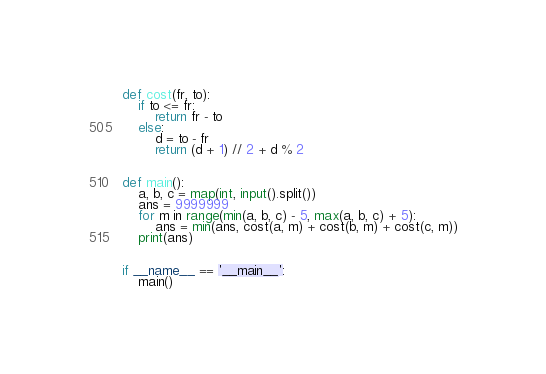<code> <loc_0><loc_0><loc_500><loc_500><_Python_>def cost(fr, to):
    if to <= fr:
        return fr - to
    else:
        d = to - fr
        return (d + 1) // 2 + d % 2


def main():
    a, b, c = map(int, input().split())
    ans = 9999999
    for m in range(min(a, b, c) - 5, max(a, b, c) + 5):
        ans = min(ans, cost(a, m) + cost(b, m) + cost(c, m))
    print(ans)


if __name__ == '__main__':
    main()</code> 